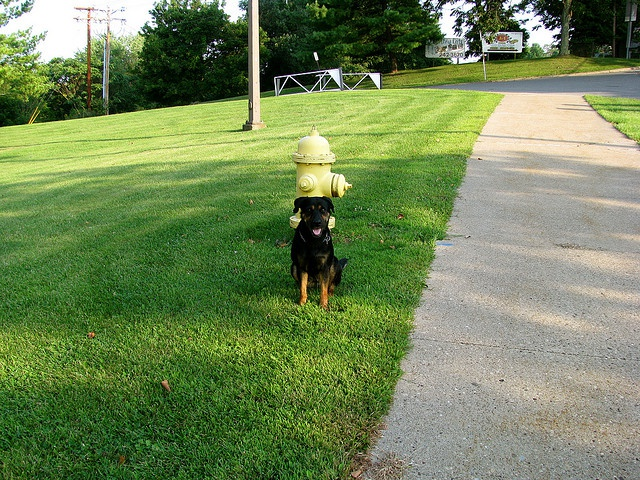Describe the objects in this image and their specific colors. I can see dog in darkgray, black, olive, maroon, and orange tones and fire hydrant in darkgray, khaki, lightyellow, and olive tones in this image. 